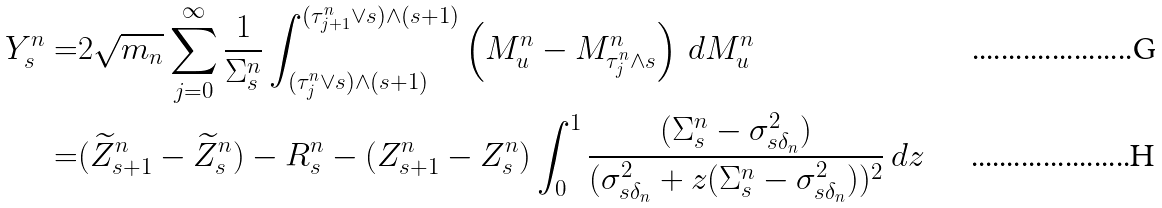Convert formula to latex. <formula><loc_0><loc_0><loc_500><loc_500>Y _ { s } ^ { n } = & 2 \sqrt { m _ { n } } \sum _ { j = 0 } ^ { \infty } \frac { 1 } { \Sigma _ { s } ^ { n } } \int _ { ( \tau _ { j } ^ { n } \vee { s } ) \wedge ( s + 1 ) } ^ { ( \tau _ { j + 1 } ^ { n } \vee { s } ) \wedge ( s + 1 ) } \left ( M ^ { n } _ { u } - M ^ { n } _ { \tau _ { j } ^ { n } \wedge { s } } \right ) \, d M ^ { n } _ { u } \\ = & ( \widetilde { Z } _ { s + 1 } ^ { n } - \widetilde { Z } _ { s } ^ { n } ) - R _ { s } ^ { n } - ( Z _ { s + 1 } ^ { n } - Z _ { s } ^ { n } ) \int _ { 0 } ^ { 1 } \frac { ( \Sigma _ { s } ^ { n } - \sigma _ { s \delta _ { n } } ^ { 2 } ) } { ( \sigma _ { s \delta _ { n } } ^ { 2 } + z ( \Sigma _ { s } ^ { n } - \sigma _ { s \delta _ { n } } ^ { 2 } ) ) ^ { 2 } } \, d z</formula> 